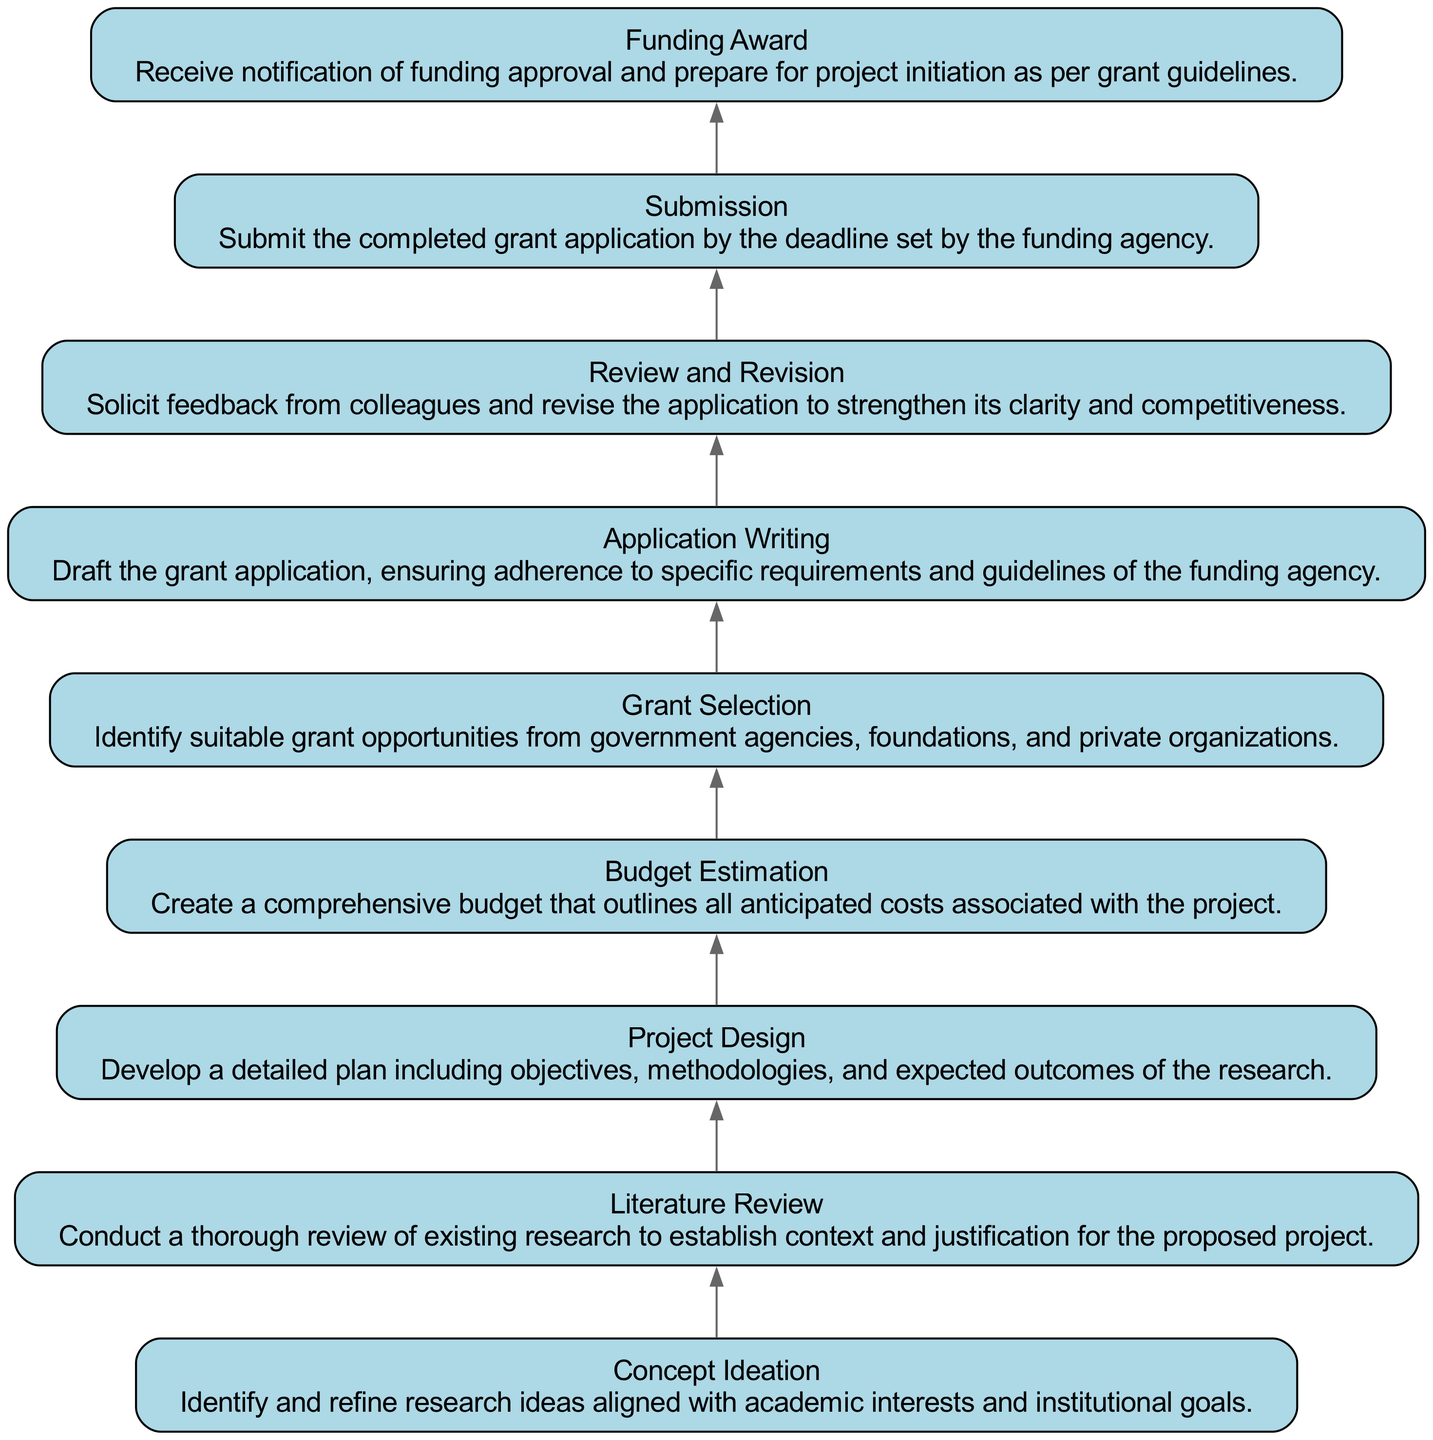What is the first step in the grant application process? The first step, as shown in the diagram, is "Concept Ideation," which is where research ideas are identified and refined.
Answer: Concept Ideation How many total nodes are in the diagram? By counting the elements listed in the diagram, there are nine distinct nodes, each representing a step in the grant application process.
Answer: Nine What step follows “Application Writing”? The diagram indicates that "Review and Revision" comes immediately after "Application Writing," where feedback is solicited and revisions are made.
Answer: Review and Revision What does the "Budget Estimation" step involve? The "Budget Estimation" node describes creating a comprehensive budget outlining all anticipated costs associated with the project.
Answer: Comprehensive budget Which node directly precedes “Funding Award”? According to the flow of the diagram, "Submission" directly precedes "Funding Award," where the completed application is submitted.
Answer: Submission Which aspect of grant selection is highlighted in this process? The "Grant Selection" node highlights identifying suitable grant opportunities from various sources, such as government agencies and foundations.
Answer: Suitable grant opportunities What is the relationship between "Literature Review" and "Project Design"? The diagram shows that "Literature Review" leads into "Project Design," indicating that understanding existing research helps in developing a detailed project plan.
Answer: Literature Review leads to Project Design In how many steps does the grant application process culminate in funding acquisition? The specific steps leading to funding acquisition can be traced to the last node, "Funding Award," which reflects the culmination of the application process.
Answer: One step What is necessary before the “Submission” step? Before "Submission," the diagram shows that "Review and Revision" is necessary to enhance the application based on feedback received from colleagues.
Answer: Review and Revision 